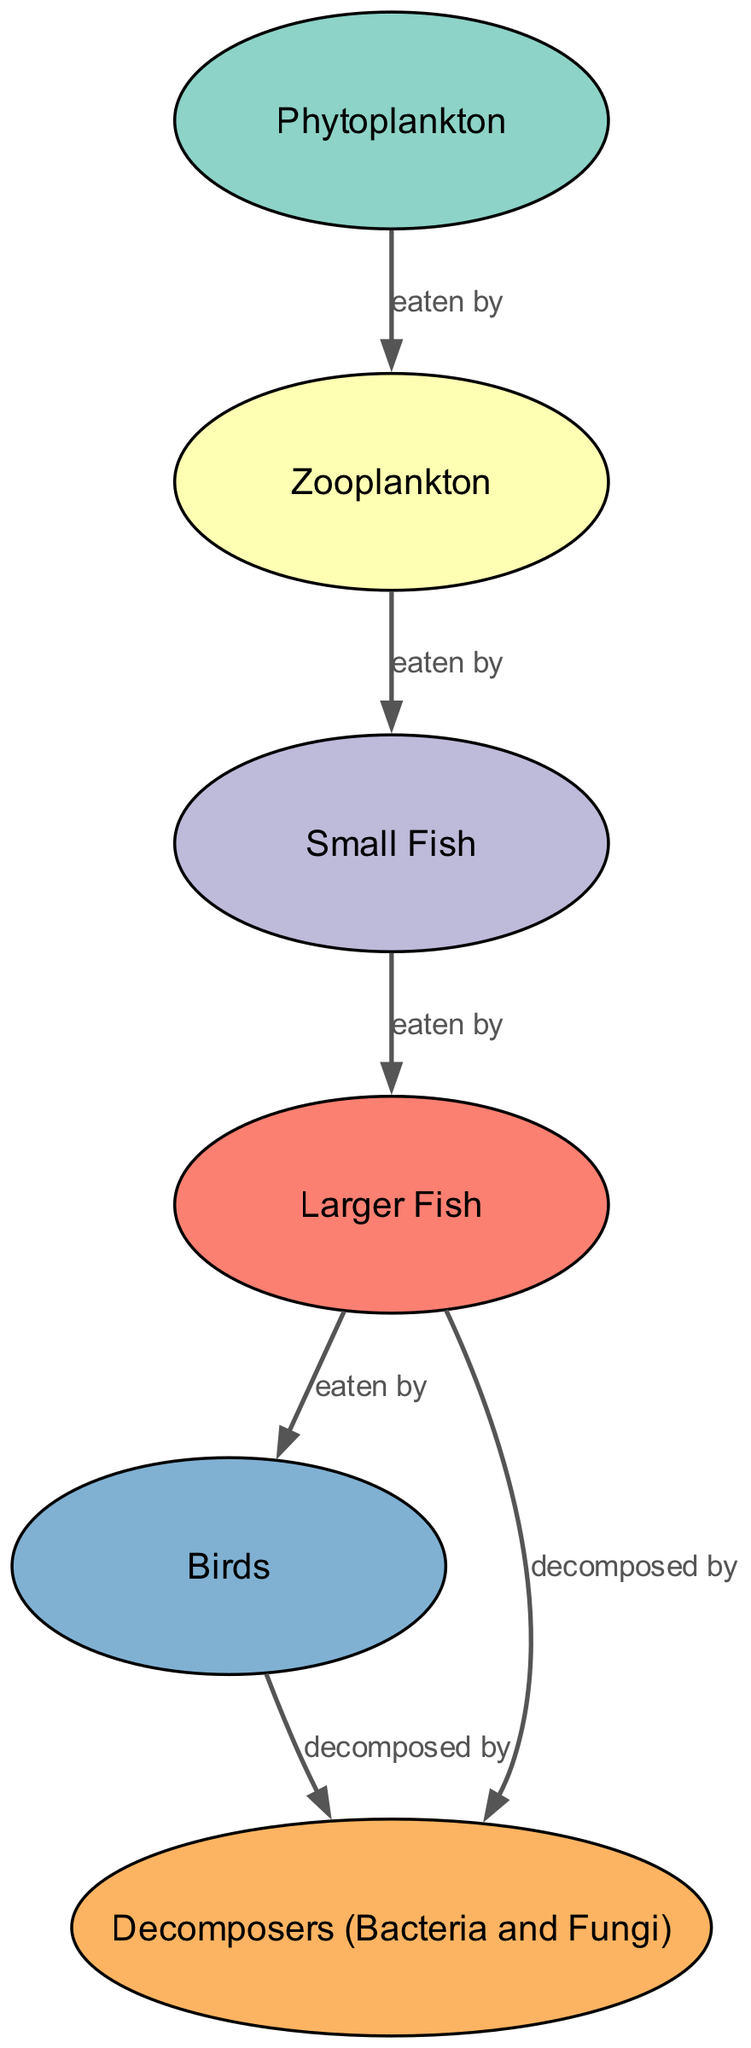What is the primary producer in this freshwater food web? The diagram identifies "Phytoplankton" as the primary producer. This information can be found in the node labeled "Phytoplankton," which is categorized as a Producer in the diagram.
Answer: Phytoplankton How many tertiary consumers are present in the food web? The diagram displays only one tertiary consumer, which is the "Larger Fish." This can be concluded by counting the nodes that are classified as Tertiary Consumers, and "Larger Fish" is the sole representative.
Answer: 1 Which organism is directly eaten by birds? According to the diagram, "Larger Fish" is directly eaten by "Birds." This relationship is represented by the edge connecting the "Larger Fish" node to the "Birds" node, indicating a direct predation relationship.
Answer: Larger Fish What type of organisms decompose both larger fish and birds in the ecosystem? The "Decomposers (Bacteria and Fungi)" are responsible for decomposing both the "Larger Fish" and "Birds." This is shown in the diagram with edges leading to the "Decomposers" node from both of these nodes.
Answer: Decomposers (Bacteria and Fungi) Identify the flow of energy from the primary consumer to the quaternary consumer in the food web. The flow of energy starts from "Zooplankton" (the primary consumer) which is eaten by "Small Fish" (the secondary consumer). Then, "Small Fish" are eaten by "Larger Fish" (the tertiary consumer), and finally, "Larger Fish" are consumed by "Birds" (the quaternary consumer). This chain of predation demonstrates the energy transfer across the food web.
Answer: Zooplankton to Small Fish to Larger Fish to Birds How many total nodes are there in this food web? The total number of nodes in the food web can be determined by counting each distinct node listed in the data, which includes six nodes: "Phytoplankton," "Zooplankton," "Small Fish," "Larger Fish," "Birds," and "Decomposers (Bacteria and Fungi)."
Answer: 6 What is the relationship between zooplankton and small fish? The relationship depicted between "Zooplankton" and "Small Fish" in the diagram is that zooplankton are eaten by small fish. This is represented by an edge connecting the two nodes with the label "eaten by."
Answer: eaten by How many relationships do decomposers have in this food web? The "Decomposers (Bacteria and Fungi)" have two distinct relationships in the food web: they decompose "Larger Fish" and also "Birds." This is seen through the two edges leading from these nodes to the decomposer node.
Answer: 2 